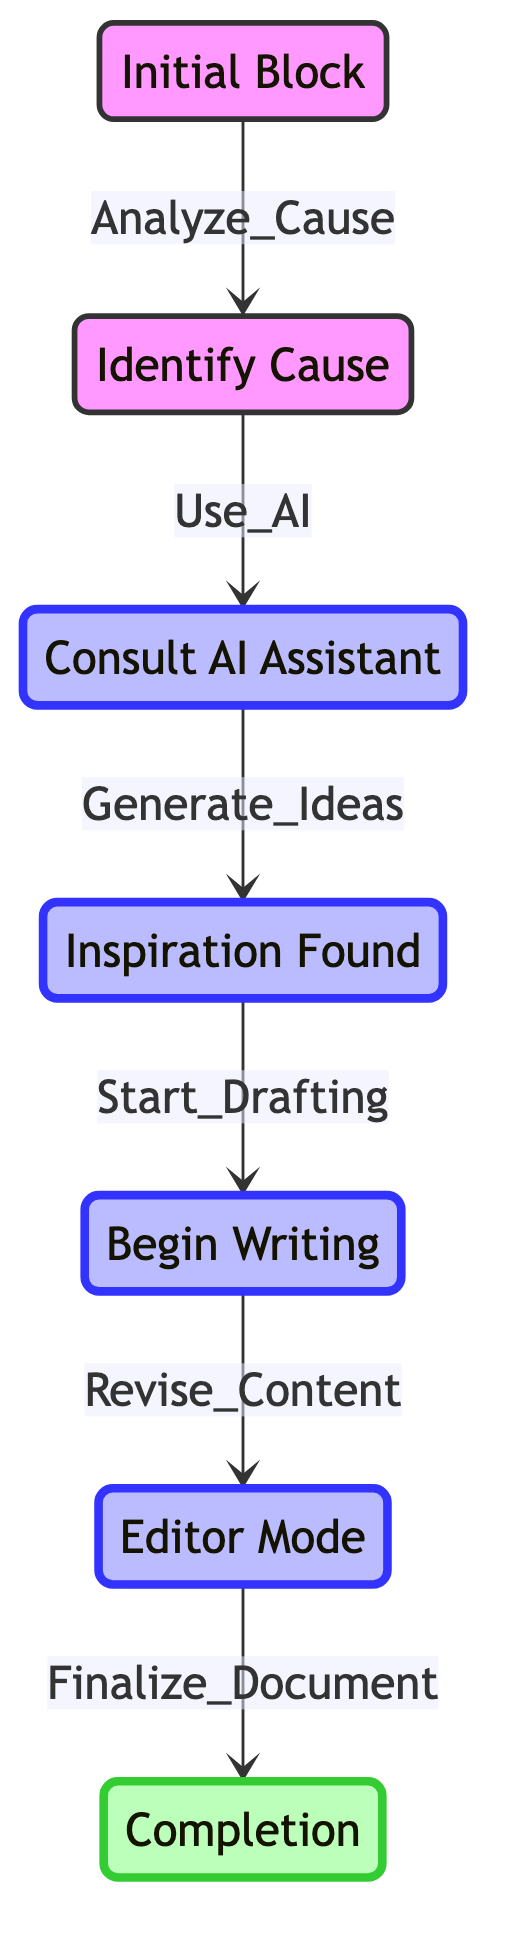What is the total number of states in the diagram? The diagram lists seven individual states: Initial Block, Identify Cause, Consult AI Assistant, Inspiration Found, Begin Writing, Editor Mode, and Completion. Counting these gives a total of 7 states.
Answer: 7 What action leads from "Initial_Block" to "Identify_Cause"? The transition from "Initial_Block" to "Identify_Cause" is represented by the action "Analyze_Cause." This is indicated by the arrow connecting these two states with the action labeled on it.
Answer: Analyze_Cause Which state is reached after "Consult_AI_Assistant"? After "Consult_AI_Assistant," the next state reached is "Inspiration_Found," as indicated by the arrow leading from "Consult_AI_Assistant" to "Inspiration_Found."
Answer: Inspiration Found What is the final state in the process? The final state in the process is "Completion," which is reached from "Editor_Mode" and signifies the end of the writer's journey through the diagram.
Answer: Completion How many direct transitions are there from "Begin_Writing"? There is one direct transition from "Begin_Writing" to "Editor_Mode," as shown by the arrow connecting these two states. This means there is only one transition emerging from "Begin_Writing."
Answer: 1 What sequence of states occurs after identifying the cause? After "Identify_Cause," the sequence of states is "Consult_AI_Assistant," then "Inspiration_Found," followed by "Begin_Writing." This sequence shows the linear progression following the identification of the cause.
Answer: Consult AI Assistant, Inspiration Found, Begin Writing Which state requires the action "Revise_Content"? The action "Revise_Content" is required to transition from "Begin_Writing" to "Editor_Mode." This action signifies the movement into the editing phase.
Answer: Editor Mode What is the action taken to move from "Inspiration_Found" to "Begin_Writing"? The action taken to move from "Inspiration_Found" to "Begin_Writing" is "Start_Drafting," which indicates the writer begins to draft content after finding inspiration.
Answer: Start Drafting 